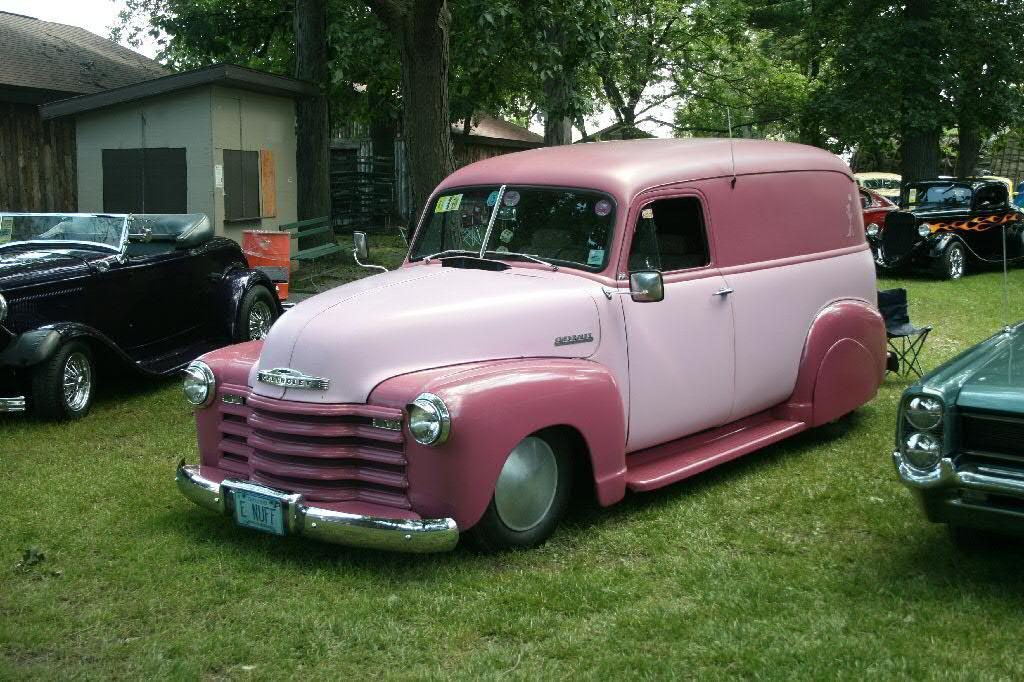What type of vehicles are on the grass in the image? There are cars on the grass in the image. What musical instrument can be seen in the image? There is a drum in the image. What type of structure is visible in the image? There is a room and a house with a shed in the image. What type of vegetation is present in the image? There are trees in the image. What type of furniture is visible in the image? There is a chair in the image. What is visible at the top of the image? The sky is visible at the top of the image. How many snakes are slithering on the drum in the image? There are no snakes present in the image; only cars, a drum, a room, a house with a shed, trees, a chair, and the sky are visible. What type of gun is being used to adjust the chair in the image? There is no gun present in the image, and the chair does not require any adjustment. 